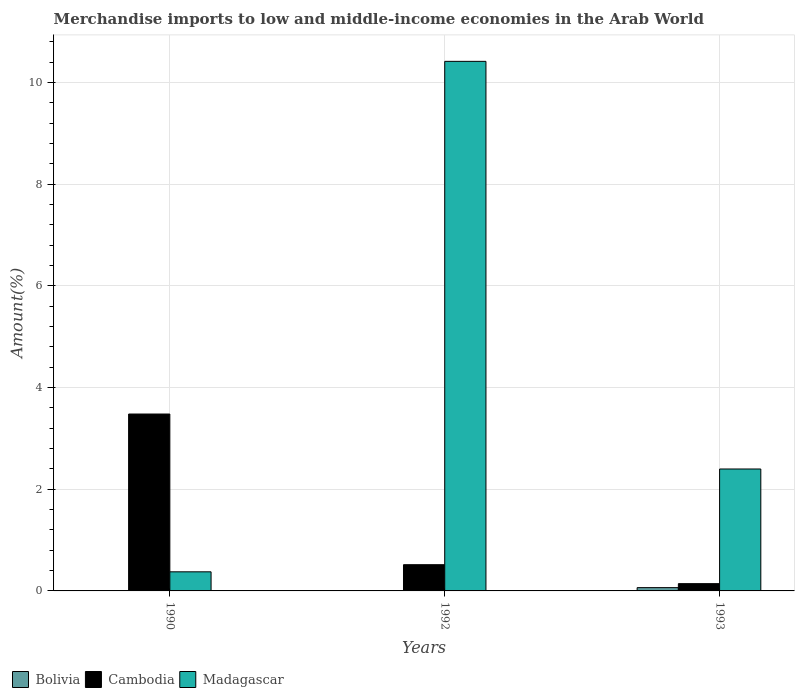How many different coloured bars are there?
Make the answer very short. 3. How many groups of bars are there?
Your response must be concise. 3. Are the number of bars on each tick of the X-axis equal?
Keep it short and to the point. Yes. How many bars are there on the 1st tick from the left?
Keep it short and to the point. 3. How many bars are there on the 2nd tick from the right?
Give a very brief answer. 3. In how many cases, is the number of bars for a given year not equal to the number of legend labels?
Keep it short and to the point. 0. What is the percentage of amount earned from merchandise imports in Madagascar in 1993?
Your response must be concise. 2.4. Across all years, what is the maximum percentage of amount earned from merchandise imports in Cambodia?
Ensure brevity in your answer.  3.48. Across all years, what is the minimum percentage of amount earned from merchandise imports in Cambodia?
Ensure brevity in your answer.  0.14. What is the total percentage of amount earned from merchandise imports in Cambodia in the graph?
Make the answer very short. 4.14. What is the difference between the percentage of amount earned from merchandise imports in Madagascar in 1990 and that in 1993?
Offer a terse response. -2.02. What is the difference between the percentage of amount earned from merchandise imports in Madagascar in 1992 and the percentage of amount earned from merchandise imports in Cambodia in 1990?
Make the answer very short. 6.94. What is the average percentage of amount earned from merchandise imports in Madagascar per year?
Ensure brevity in your answer.  4.4. In the year 1990, what is the difference between the percentage of amount earned from merchandise imports in Cambodia and percentage of amount earned from merchandise imports in Bolivia?
Give a very brief answer. 3.47. In how many years, is the percentage of amount earned from merchandise imports in Madagascar greater than 2.4 %?
Make the answer very short. 1. What is the ratio of the percentage of amount earned from merchandise imports in Madagascar in 1990 to that in 1992?
Keep it short and to the point. 0.04. What is the difference between the highest and the second highest percentage of amount earned from merchandise imports in Cambodia?
Your response must be concise. 2.96. What is the difference between the highest and the lowest percentage of amount earned from merchandise imports in Bolivia?
Make the answer very short. 0.06. In how many years, is the percentage of amount earned from merchandise imports in Cambodia greater than the average percentage of amount earned from merchandise imports in Cambodia taken over all years?
Your answer should be very brief. 1. What does the 3rd bar from the left in 1990 represents?
Ensure brevity in your answer.  Madagascar. What does the 3rd bar from the right in 1992 represents?
Your response must be concise. Bolivia. Is it the case that in every year, the sum of the percentage of amount earned from merchandise imports in Cambodia and percentage of amount earned from merchandise imports in Madagascar is greater than the percentage of amount earned from merchandise imports in Bolivia?
Keep it short and to the point. Yes. Are all the bars in the graph horizontal?
Make the answer very short. No. How many years are there in the graph?
Your answer should be very brief. 3. What is the difference between two consecutive major ticks on the Y-axis?
Your answer should be very brief. 2. Are the values on the major ticks of Y-axis written in scientific E-notation?
Your answer should be compact. No. Does the graph contain grids?
Your response must be concise. Yes. Where does the legend appear in the graph?
Make the answer very short. Bottom left. How many legend labels are there?
Keep it short and to the point. 3. What is the title of the graph?
Make the answer very short. Merchandise imports to low and middle-income economies in the Arab World. What is the label or title of the Y-axis?
Make the answer very short. Amount(%). What is the Amount(%) in Bolivia in 1990?
Your answer should be very brief. 0.01. What is the Amount(%) of Cambodia in 1990?
Provide a short and direct response. 3.48. What is the Amount(%) in Madagascar in 1990?
Provide a short and direct response. 0.38. What is the Amount(%) of Bolivia in 1992?
Make the answer very short. 0. What is the Amount(%) of Cambodia in 1992?
Offer a terse response. 0.52. What is the Amount(%) in Madagascar in 1992?
Provide a short and direct response. 10.42. What is the Amount(%) in Bolivia in 1993?
Provide a short and direct response. 0.06. What is the Amount(%) of Cambodia in 1993?
Keep it short and to the point. 0.14. What is the Amount(%) of Madagascar in 1993?
Make the answer very short. 2.4. Across all years, what is the maximum Amount(%) in Bolivia?
Your answer should be compact. 0.06. Across all years, what is the maximum Amount(%) in Cambodia?
Your response must be concise. 3.48. Across all years, what is the maximum Amount(%) of Madagascar?
Your answer should be very brief. 10.42. Across all years, what is the minimum Amount(%) in Bolivia?
Offer a terse response. 0. Across all years, what is the minimum Amount(%) in Cambodia?
Give a very brief answer. 0.14. Across all years, what is the minimum Amount(%) in Madagascar?
Make the answer very short. 0.38. What is the total Amount(%) in Bolivia in the graph?
Give a very brief answer. 0.08. What is the total Amount(%) of Cambodia in the graph?
Offer a very short reply. 4.14. What is the total Amount(%) in Madagascar in the graph?
Offer a very short reply. 13.19. What is the difference between the Amount(%) of Bolivia in 1990 and that in 1992?
Provide a short and direct response. 0. What is the difference between the Amount(%) of Cambodia in 1990 and that in 1992?
Give a very brief answer. 2.96. What is the difference between the Amount(%) in Madagascar in 1990 and that in 1992?
Make the answer very short. -10.04. What is the difference between the Amount(%) of Bolivia in 1990 and that in 1993?
Your answer should be very brief. -0.06. What is the difference between the Amount(%) of Cambodia in 1990 and that in 1993?
Your answer should be compact. 3.34. What is the difference between the Amount(%) in Madagascar in 1990 and that in 1993?
Ensure brevity in your answer.  -2.02. What is the difference between the Amount(%) of Bolivia in 1992 and that in 1993?
Your answer should be compact. -0.06. What is the difference between the Amount(%) of Cambodia in 1992 and that in 1993?
Keep it short and to the point. 0.37. What is the difference between the Amount(%) in Madagascar in 1992 and that in 1993?
Your response must be concise. 8.02. What is the difference between the Amount(%) in Bolivia in 1990 and the Amount(%) in Cambodia in 1992?
Provide a short and direct response. -0.51. What is the difference between the Amount(%) of Bolivia in 1990 and the Amount(%) of Madagascar in 1992?
Give a very brief answer. -10.41. What is the difference between the Amount(%) of Cambodia in 1990 and the Amount(%) of Madagascar in 1992?
Your response must be concise. -6.94. What is the difference between the Amount(%) in Bolivia in 1990 and the Amount(%) in Cambodia in 1993?
Your response must be concise. -0.13. What is the difference between the Amount(%) of Bolivia in 1990 and the Amount(%) of Madagascar in 1993?
Offer a terse response. -2.39. What is the difference between the Amount(%) in Cambodia in 1990 and the Amount(%) in Madagascar in 1993?
Give a very brief answer. 1.08. What is the difference between the Amount(%) in Bolivia in 1992 and the Amount(%) in Cambodia in 1993?
Your answer should be compact. -0.14. What is the difference between the Amount(%) of Bolivia in 1992 and the Amount(%) of Madagascar in 1993?
Provide a succinct answer. -2.39. What is the difference between the Amount(%) in Cambodia in 1992 and the Amount(%) in Madagascar in 1993?
Your answer should be compact. -1.88. What is the average Amount(%) of Bolivia per year?
Give a very brief answer. 0.03. What is the average Amount(%) of Cambodia per year?
Your response must be concise. 1.38. What is the average Amount(%) of Madagascar per year?
Offer a terse response. 4.4. In the year 1990, what is the difference between the Amount(%) in Bolivia and Amount(%) in Cambodia?
Your response must be concise. -3.47. In the year 1990, what is the difference between the Amount(%) of Bolivia and Amount(%) of Madagascar?
Keep it short and to the point. -0.37. In the year 1990, what is the difference between the Amount(%) of Cambodia and Amount(%) of Madagascar?
Offer a very short reply. 3.1. In the year 1992, what is the difference between the Amount(%) in Bolivia and Amount(%) in Cambodia?
Keep it short and to the point. -0.51. In the year 1992, what is the difference between the Amount(%) of Bolivia and Amount(%) of Madagascar?
Keep it short and to the point. -10.41. In the year 1992, what is the difference between the Amount(%) in Cambodia and Amount(%) in Madagascar?
Make the answer very short. -9.9. In the year 1993, what is the difference between the Amount(%) in Bolivia and Amount(%) in Cambodia?
Provide a succinct answer. -0.08. In the year 1993, what is the difference between the Amount(%) of Bolivia and Amount(%) of Madagascar?
Provide a short and direct response. -2.33. In the year 1993, what is the difference between the Amount(%) of Cambodia and Amount(%) of Madagascar?
Make the answer very short. -2.26. What is the ratio of the Amount(%) in Bolivia in 1990 to that in 1992?
Provide a short and direct response. 1.78. What is the ratio of the Amount(%) in Cambodia in 1990 to that in 1992?
Ensure brevity in your answer.  6.75. What is the ratio of the Amount(%) of Madagascar in 1990 to that in 1992?
Keep it short and to the point. 0.04. What is the ratio of the Amount(%) in Bolivia in 1990 to that in 1993?
Provide a short and direct response. 0.13. What is the ratio of the Amount(%) of Cambodia in 1990 to that in 1993?
Make the answer very short. 24.31. What is the ratio of the Amount(%) of Madagascar in 1990 to that in 1993?
Your answer should be very brief. 0.16. What is the ratio of the Amount(%) in Bolivia in 1992 to that in 1993?
Offer a very short reply. 0.07. What is the ratio of the Amount(%) of Cambodia in 1992 to that in 1993?
Ensure brevity in your answer.  3.6. What is the ratio of the Amount(%) in Madagascar in 1992 to that in 1993?
Provide a succinct answer. 4.34. What is the difference between the highest and the second highest Amount(%) in Bolivia?
Give a very brief answer. 0.06. What is the difference between the highest and the second highest Amount(%) in Cambodia?
Provide a succinct answer. 2.96. What is the difference between the highest and the second highest Amount(%) of Madagascar?
Keep it short and to the point. 8.02. What is the difference between the highest and the lowest Amount(%) of Bolivia?
Ensure brevity in your answer.  0.06. What is the difference between the highest and the lowest Amount(%) in Cambodia?
Offer a very short reply. 3.34. What is the difference between the highest and the lowest Amount(%) in Madagascar?
Your response must be concise. 10.04. 